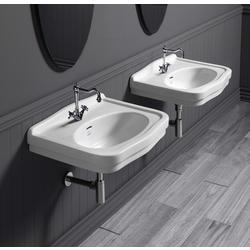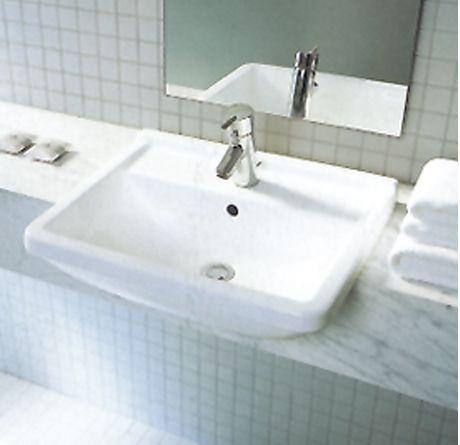The first image is the image on the left, the second image is the image on the right. Assess this claim about the two images: "Exactly two bathroom sinks are shown, one with hot and cold water faucets, while the other has a single unright faucet.". Correct or not? Answer yes or no. No. The first image is the image on the left, the second image is the image on the right. For the images displayed, is the sentence "The combined images include two wall-mounted sinks with metal pipes exposed underneath them, and at least one sink has faucets integrated with the spout." factually correct? Answer yes or no. Yes. 